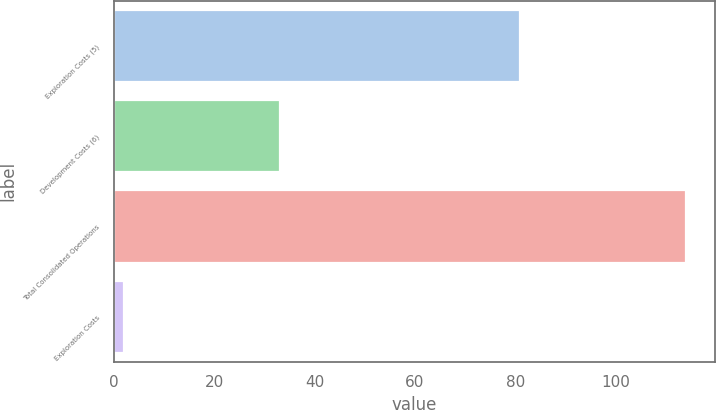Convert chart to OTSL. <chart><loc_0><loc_0><loc_500><loc_500><bar_chart><fcel>Exploration Costs (5)<fcel>Development Costs (6)<fcel>Total Consolidated Operations<fcel>Exploration Costs<nl><fcel>81<fcel>33<fcel>114<fcel>2<nl></chart> 